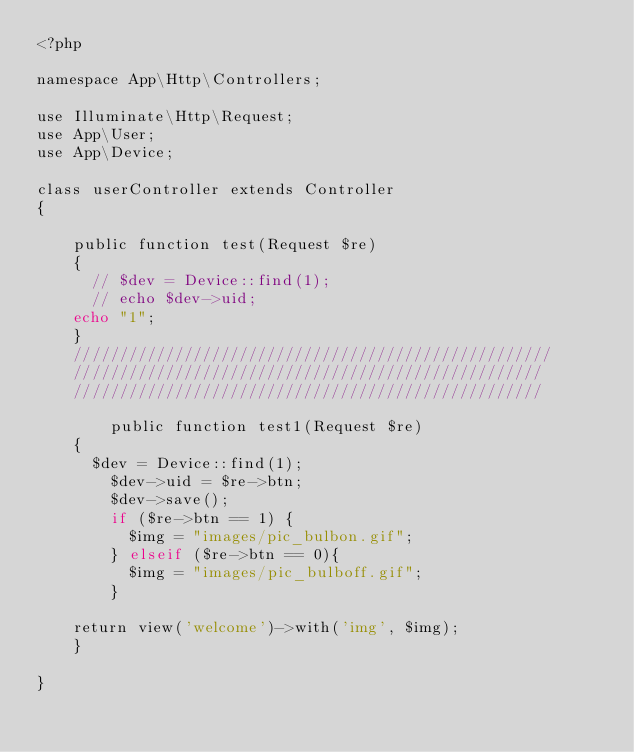Convert code to text. <code><loc_0><loc_0><loc_500><loc_500><_PHP_><?php

namespace App\Http\Controllers;

use Illuminate\Http\Request;
use App\User;
use App\Device;

class userController extends Controller
{

    public function test(Request $re)
    {
    	// $dev = Device::find(1);
    	// echo $dev->uid;
    echo "1";
    }
    ////////////////////////////////////////////////////
    ///////////////////////////////////////////////////
    ///////////////////////////////////////////////////

        public function test1(Request $re)
    {
    	$dev = Device::find(1);
        $dev->uid = $re->btn;
        $dev->save();
        if ($re->btn == 1) {
        	$img = "images/pic_bulbon.gif";
        } elseif ($re->btn == 0){
        	$img = "images/pic_bulboff.gif";
        }
        
		return view('welcome')->with('img', $img);
    }

}
</code> 